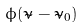<formula> <loc_0><loc_0><loc_500><loc_500>\phi ( \tilde { \nu } - \tilde { \nu } _ { 0 } )</formula> 